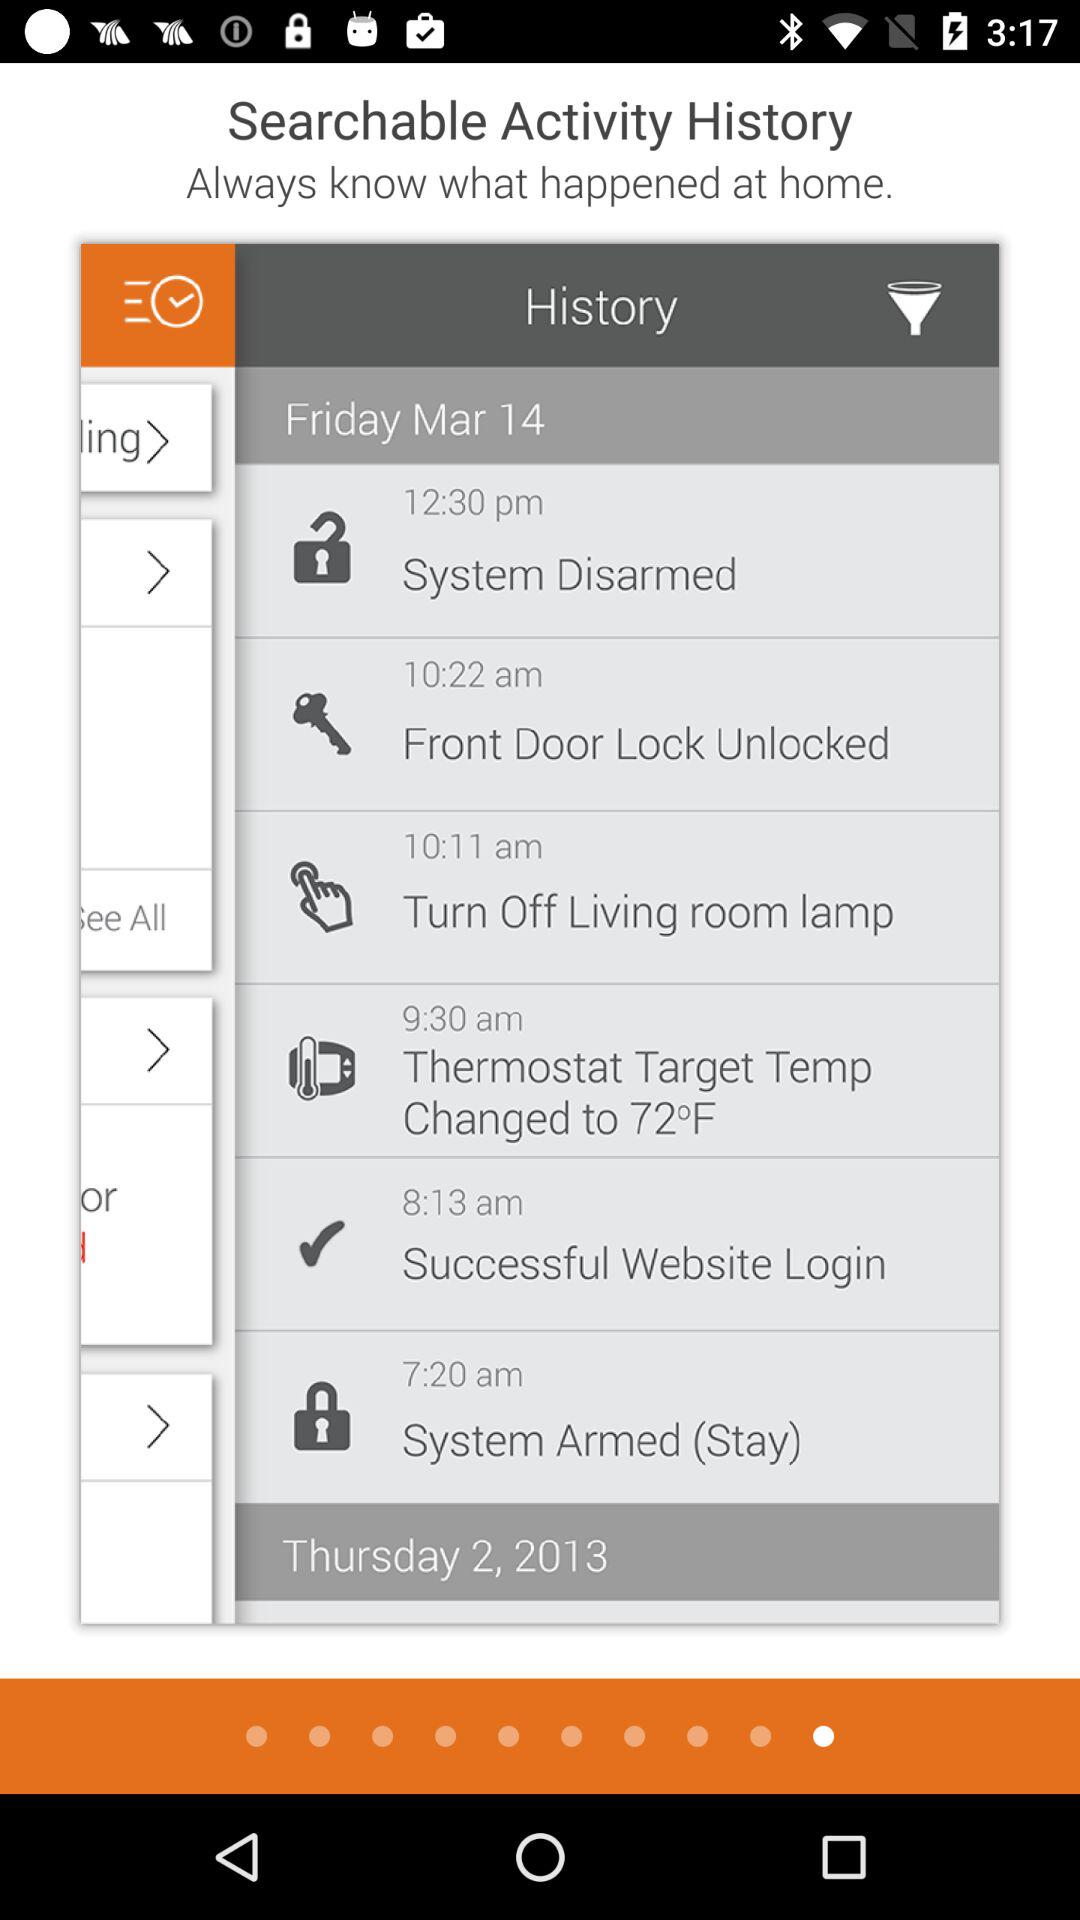How many days are shown in the history?
Answer the question using a single word or phrase. 2 